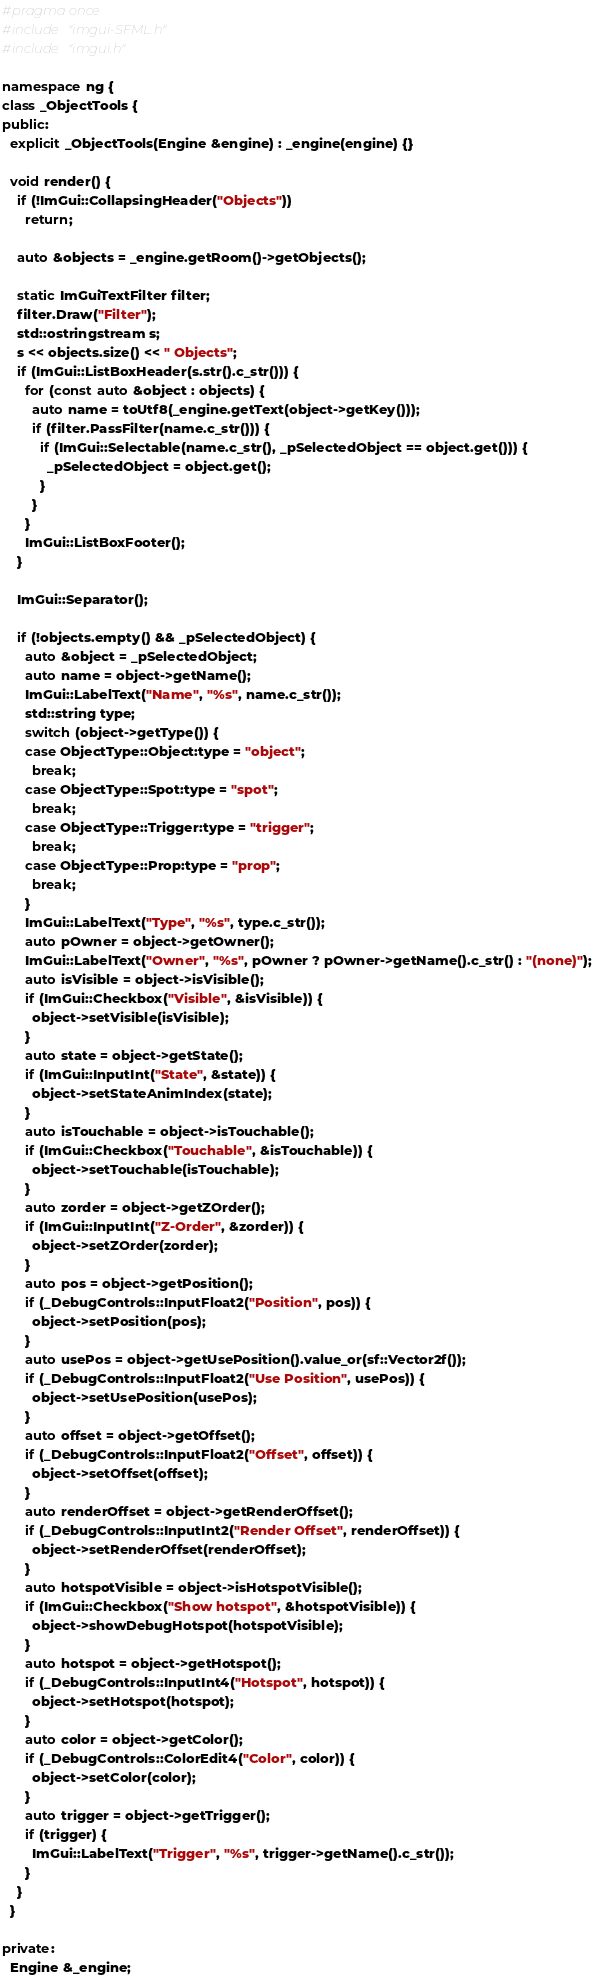<code> <loc_0><loc_0><loc_500><loc_500><_C++_>#pragma once
#include "imgui-SFML.h"
#include "imgui.h"

namespace ng {
class _ObjectTools {
public:
  explicit _ObjectTools(Engine &engine) : _engine(engine) {}

  void render() {
    if (!ImGui::CollapsingHeader("Objects"))
      return;

    auto &objects = _engine.getRoom()->getObjects();

    static ImGuiTextFilter filter;
    filter.Draw("Filter");
    std::ostringstream s;
    s << objects.size() << " Objects";
    if (ImGui::ListBoxHeader(s.str().c_str())) {
      for (const auto &object : objects) {
        auto name = toUtf8(_engine.getText(object->getKey()));
        if (filter.PassFilter(name.c_str())) {
          if (ImGui::Selectable(name.c_str(), _pSelectedObject == object.get())) {
            _pSelectedObject = object.get();
          }
        }
      }
      ImGui::ListBoxFooter();
    }

    ImGui::Separator();

    if (!objects.empty() && _pSelectedObject) {
      auto &object = _pSelectedObject;
      auto name = object->getName();
      ImGui::LabelText("Name", "%s", name.c_str());
      std::string type;
      switch (object->getType()) {
      case ObjectType::Object:type = "object";
        break;
      case ObjectType::Spot:type = "spot";
        break;
      case ObjectType::Trigger:type = "trigger";
        break;
      case ObjectType::Prop:type = "prop";
        break;
      }
      ImGui::LabelText("Type", "%s", type.c_str());
      auto pOwner = object->getOwner();
      ImGui::LabelText("Owner", "%s", pOwner ? pOwner->getName().c_str() : "(none)");
      auto isVisible = object->isVisible();
      if (ImGui::Checkbox("Visible", &isVisible)) {
        object->setVisible(isVisible);
      }
      auto state = object->getState();
      if (ImGui::InputInt("State", &state)) {
        object->setStateAnimIndex(state);
      }
      auto isTouchable = object->isTouchable();
      if (ImGui::Checkbox("Touchable", &isTouchable)) {
        object->setTouchable(isTouchable);
      }
      auto zorder = object->getZOrder();
      if (ImGui::InputInt("Z-Order", &zorder)) {
        object->setZOrder(zorder);
      }
      auto pos = object->getPosition();
      if (_DebugControls::InputFloat2("Position", pos)) {
        object->setPosition(pos);
      }
      auto usePos = object->getUsePosition().value_or(sf::Vector2f());
      if (_DebugControls::InputFloat2("Use Position", usePos)) {
        object->setUsePosition(usePos);
      }
      auto offset = object->getOffset();
      if (_DebugControls::InputFloat2("Offset", offset)) {
        object->setOffset(offset);
      }
      auto renderOffset = object->getRenderOffset();
      if (_DebugControls::InputInt2("Render Offset", renderOffset)) {
        object->setRenderOffset(renderOffset);
      }
      auto hotspotVisible = object->isHotspotVisible();
      if (ImGui::Checkbox("Show hotspot", &hotspotVisible)) {
        object->showDebugHotspot(hotspotVisible);
      }
      auto hotspot = object->getHotspot();
      if (_DebugControls::InputInt4("Hotspot", hotspot)) {
        object->setHotspot(hotspot);
      }
      auto color = object->getColor();
      if (_DebugControls::ColorEdit4("Color", color)) {
        object->setColor(color);
      }
      auto trigger = object->getTrigger();
      if (trigger) {
        ImGui::LabelText("Trigger", "%s", trigger->getName().c_str());
      }
    }
  }

private:
  Engine &_engine;</code> 